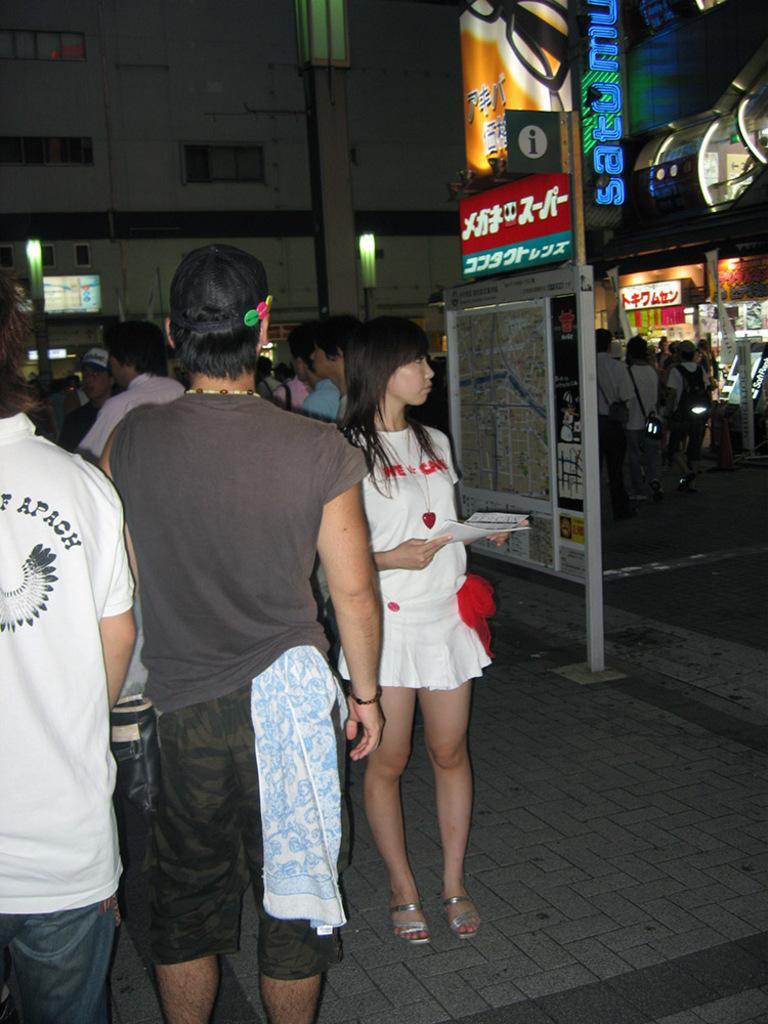Can you describe this image briefly? In this image we can see many people. There is onboard with something on that. Also there are name boards. In the back we can see lights. Also there are lights. 